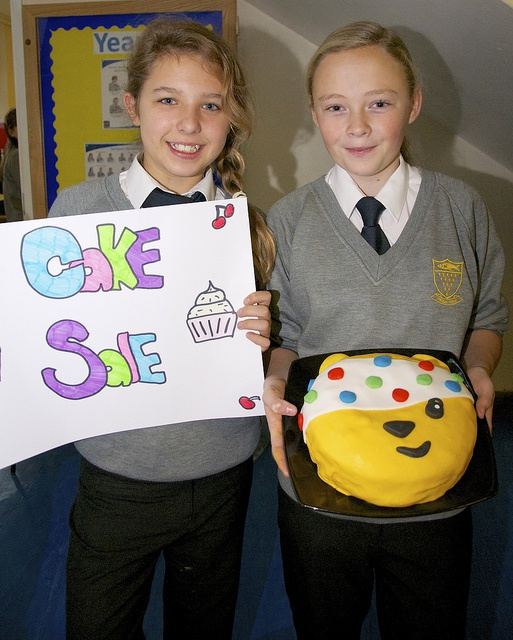Describe the objects in this image and their specific colors. I can see people in olive, black, gray, and gold tones, people in olive, black, gray, maroon, and tan tones, cake in olive, gold, lightgray, and black tones, tie in olive, black, gray, and darkgray tones, and tie in olive, black, gray, and darkgray tones in this image. 